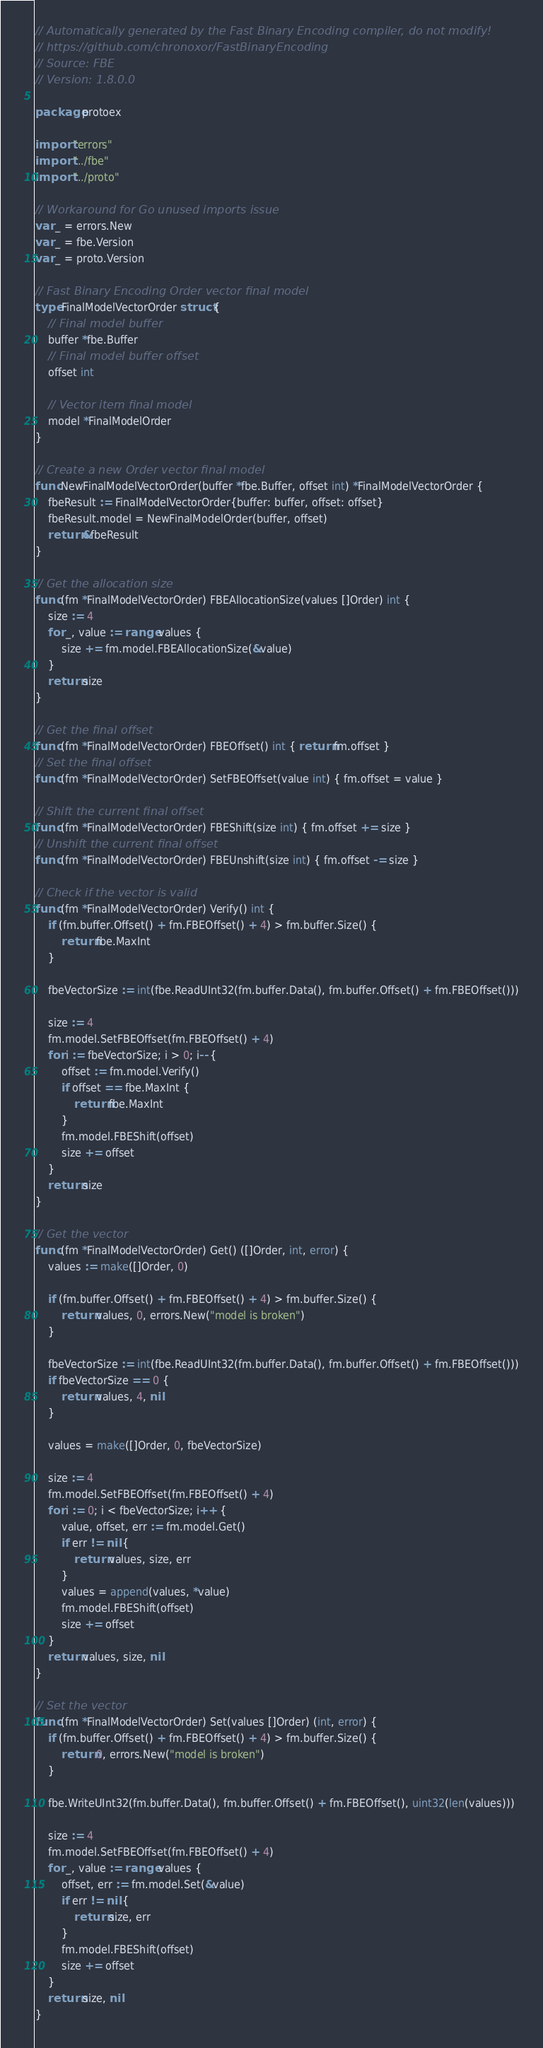Convert code to text. <code><loc_0><loc_0><loc_500><loc_500><_Go_>// Automatically generated by the Fast Binary Encoding compiler, do not modify!
// https://github.com/chronoxor/FastBinaryEncoding
// Source: FBE
// Version: 1.8.0.0

package protoex

import "errors"
import "../fbe"
import "../proto"

// Workaround for Go unused imports issue
var _ = errors.New
var _ = fbe.Version
var _ = proto.Version

// Fast Binary Encoding Order vector final model
type FinalModelVectorOrder struct {
    // Final model buffer
    buffer *fbe.Buffer
    // Final model buffer offset
    offset int

    // Vector item final model
    model *FinalModelOrder
}

// Create a new Order vector final model
func NewFinalModelVectorOrder(buffer *fbe.Buffer, offset int) *FinalModelVectorOrder {
    fbeResult := FinalModelVectorOrder{buffer: buffer, offset: offset}
    fbeResult.model = NewFinalModelOrder(buffer, offset)
    return &fbeResult
}

// Get the allocation size
func (fm *FinalModelVectorOrder) FBEAllocationSize(values []Order) int {
    size := 4
    for _, value := range values {
        size += fm.model.FBEAllocationSize(&value)
    }
    return size
}

// Get the final offset
func (fm *FinalModelVectorOrder) FBEOffset() int { return fm.offset }
// Set the final offset
func (fm *FinalModelVectorOrder) SetFBEOffset(value int) { fm.offset = value }

// Shift the current final offset
func (fm *FinalModelVectorOrder) FBEShift(size int) { fm.offset += size }
// Unshift the current final offset
func (fm *FinalModelVectorOrder) FBEUnshift(size int) { fm.offset -= size }

// Check if the vector is valid
func (fm *FinalModelVectorOrder) Verify() int {
    if (fm.buffer.Offset() + fm.FBEOffset() + 4) > fm.buffer.Size() {
        return fbe.MaxInt
    }

    fbeVectorSize := int(fbe.ReadUInt32(fm.buffer.Data(), fm.buffer.Offset() + fm.FBEOffset()))

    size := 4
    fm.model.SetFBEOffset(fm.FBEOffset() + 4)
    for i := fbeVectorSize; i > 0; i-- {
        offset := fm.model.Verify()
        if offset == fbe.MaxInt {
            return fbe.MaxInt
        }
        fm.model.FBEShift(offset)
        size += offset
    }
    return size
}

// Get the vector
func (fm *FinalModelVectorOrder) Get() ([]Order, int, error) {
    values := make([]Order, 0)

    if (fm.buffer.Offset() + fm.FBEOffset() + 4) > fm.buffer.Size() {
        return values, 0, errors.New("model is broken")
    }

    fbeVectorSize := int(fbe.ReadUInt32(fm.buffer.Data(), fm.buffer.Offset() + fm.FBEOffset()))
    if fbeVectorSize == 0 {
        return values, 4, nil
    }

    values = make([]Order, 0, fbeVectorSize)

    size := 4
    fm.model.SetFBEOffset(fm.FBEOffset() + 4)
    for i := 0; i < fbeVectorSize; i++ {
        value, offset, err := fm.model.Get()
        if err != nil {
            return values, size, err
        }
        values = append(values, *value)
        fm.model.FBEShift(offset)
        size += offset
    }
    return values, size, nil
}

// Set the vector
func (fm *FinalModelVectorOrder) Set(values []Order) (int, error) {
    if (fm.buffer.Offset() + fm.FBEOffset() + 4) > fm.buffer.Size() {
        return 0, errors.New("model is broken")
    }

    fbe.WriteUInt32(fm.buffer.Data(), fm.buffer.Offset() + fm.FBEOffset(), uint32(len(values)))

    size := 4
    fm.model.SetFBEOffset(fm.FBEOffset() + 4)
    for _, value := range values {
        offset, err := fm.model.Set(&value)
        if err != nil {
            return size, err
        }
        fm.model.FBEShift(offset)
        size += offset
    }
    return size, nil
}
</code> 